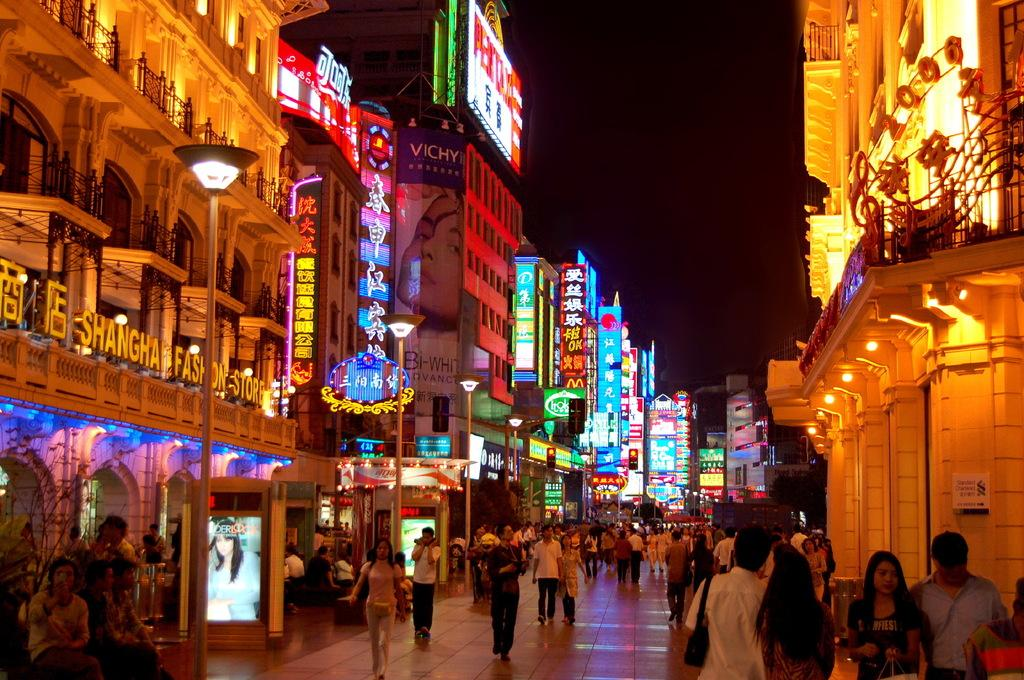<image>
Relay a brief, clear account of the picture shown. Many people walk past the shops, including the Shanghai Fashion Store. 